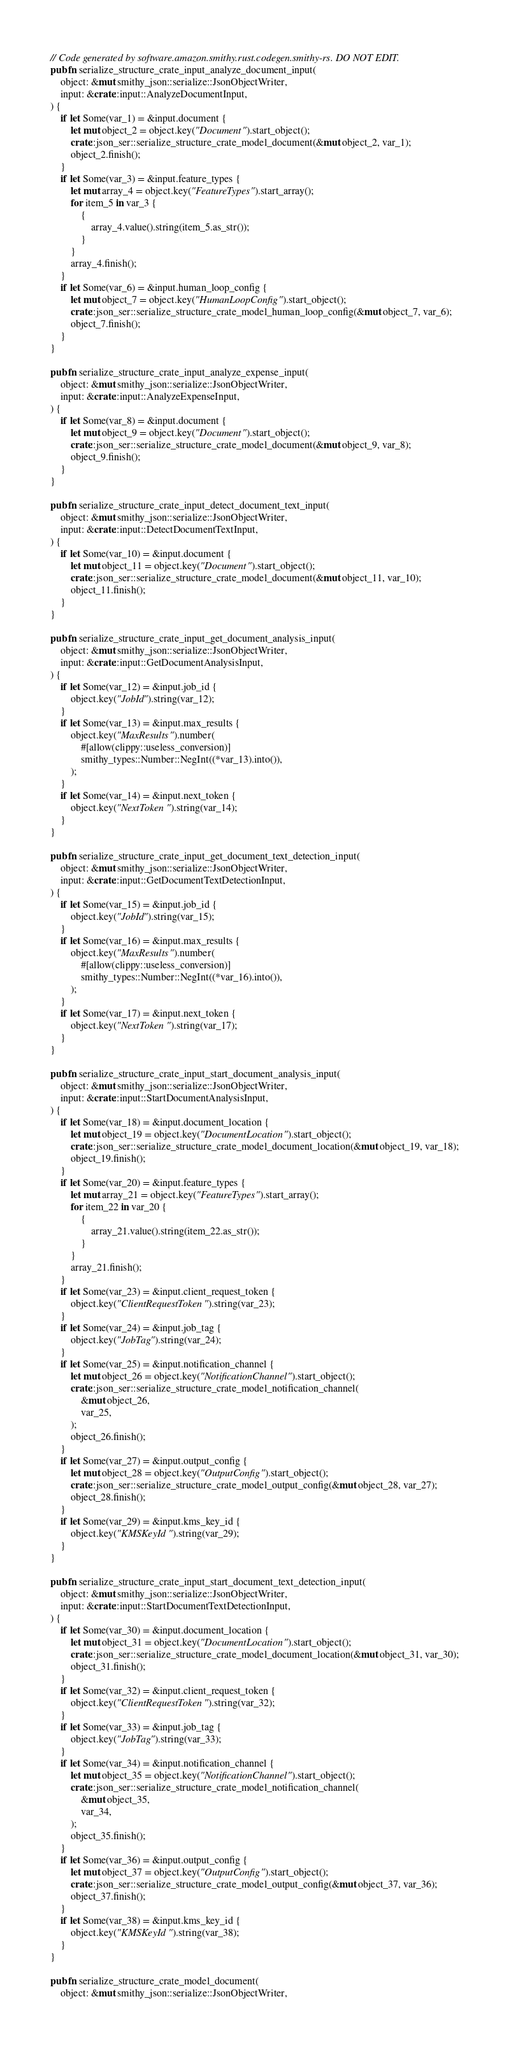Convert code to text. <code><loc_0><loc_0><loc_500><loc_500><_Rust_>// Code generated by software.amazon.smithy.rust.codegen.smithy-rs. DO NOT EDIT.
pub fn serialize_structure_crate_input_analyze_document_input(
    object: &mut smithy_json::serialize::JsonObjectWriter,
    input: &crate::input::AnalyzeDocumentInput,
) {
    if let Some(var_1) = &input.document {
        let mut object_2 = object.key("Document").start_object();
        crate::json_ser::serialize_structure_crate_model_document(&mut object_2, var_1);
        object_2.finish();
    }
    if let Some(var_3) = &input.feature_types {
        let mut array_4 = object.key("FeatureTypes").start_array();
        for item_5 in var_3 {
            {
                array_4.value().string(item_5.as_str());
            }
        }
        array_4.finish();
    }
    if let Some(var_6) = &input.human_loop_config {
        let mut object_7 = object.key("HumanLoopConfig").start_object();
        crate::json_ser::serialize_structure_crate_model_human_loop_config(&mut object_7, var_6);
        object_7.finish();
    }
}

pub fn serialize_structure_crate_input_analyze_expense_input(
    object: &mut smithy_json::serialize::JsonObjectWriter,
    input: &crate::input::AnalyzeExpenseInput,
) {
    if let Some(var_8) = &input.document {
        let mut object_9 = object.key("Document").start_object();
        crate::json_ser::serialize_structure_crate_model_document(&mut object_9, var_8);
        object_9.finish();
    }
}

pub fn serialize_structure_crate_input_detect_document_text_input(
    object: &mut smithy_json::serialize::JsonObjectWriter,
    input: &crate::input::DetectDocumentTextInput,
) {
    if let Some(var_10) = &input.document {
        let mut object_11 = object.key("Document").start_object();
        crate::json_ser::serialize_structure_crate_model_document(&mut object_11, var_10);
        object_11.finish();
    }
}

pub fn serialize_structure_crate_input_get_document_analysis_input(
    object: &mut smithy_json::serialize::JsonObjectWriter,
    input: &crate::input::GetDocumentAnalysisInput,
) {
    if let Some(var_12) = &input.job_id {
        object.key("JobId").string(var_12);
    }
    if let Some(var_13) = &input.max_results {
        object.key("MaxResults").number(
            #[allow(clippy::useless_conversion)]
            smithy_types::Number::NegInt((*var_13).into()),
        );
    }
    if let Some(var_14) = &input.next_token {
        object.key("NextToken").string(var_14);
    }
}

pub fn serialize_structure_crate_input_get_document_text_detection_input(
    object: &mut smithy_json::serialize::JsonObjectWriter,
    input: &crate::input::GetDocumentTextDetectionInput,
) {
    if let Some(var_15) = &input.job_id {
        object.key("JobId").string(var_15);
    }
    if let Some(var_16) = &input.max_results {
        object.key("MaxResults").number(
            #[allow(clippy::useless_conversion)]
            smithy_types::Number::NegInt((*var_16).into()),
        );
    }
    if let Some(var_17) = &input.next_token {
        object.key("NextToken").string(var_17);
    }
}

pub fn serialize_structure_crate_input_start_document_analysis_input(
    object: &mut smithy_json::serialize::JsonObjectWriter,
    input: &crate::input::StartDocumentAnalysisInput,
) {
    if let Some(var_18) = &input.document_location {
        let mut object_19 = object.key("DocumentLocation").start_object();
        crate::json_ser::serialize_structure_crate_model_document_location(&mut object_19, var_18);
        object_19.finish();
    }
    if let Some(var_20) = &input.feature_types {
        let mut array_21 = object.key("FeatureTypes").start_array();
        for item_22 in var_20 {
            {
                array_21.value().string(item_22.as_str());
            }
        }
        array_21.finish();
    }
    if let Some(var_23) = &input.client_request_token {
        object.key("ClientRequestToken").string(var_23);
    }
    if let Some(var_24) = &input.job_tag {
        object.key("JobTag").string(var_24);
    }
    if let Some(var_25) = &input.notification_channel {
        let mut object_26 = object.key("NotificationChannel").start_object();
        crate::json_ser::serialize_structure_crate_model_notification_channel(
            &mut object_26,
            var_25,
        );
        object_26.finish();
    }
    if let Some(var_27) = &input.output_config {
        let mut object_28 = object.key("OutputConfig").start_object();
        crate::json_ser::serialize_structure_crate_model_output_config(&mut object_28, var_27);
        object_28.finish();
    }
    if let Some(var_29) = &input.kms_key_id {
        object.key("KMSKeyId").string(var_29);
    }
}

pub fn serialize_structure_crate_input_start_document_text_detection_input(
    object: &mut smithy_json::serialize::JsonObjectWriter,
    input: &crate::input::StartDocumentTextDetectionInput,
) {
    if let Some(var_30) = &input.document_location {
        let mut object_31 = object.key("DocumentLocation").start_object();
        crate::json_ser::serialize_structure_crate_model_document_location(&mut object_31, var_30);
        object_31.finish();
    }
    if let Some(var_32) = &input.client_request_token {
        object.key("ClientRequestToken").string(var_32);
    }
    if let Some(var_33) = &input.job_tag {
        object.key("JobTag").string(var_33);
    }
    if let Some(var_34) = &input.notification_channel {
        let mut object_35 = object.key("NotificationChannel").start_object();
        crate::json_ser::serialize_structure_crate_model_notification_channel(
            &mut object_35,
            var_34,
        );
        object_35.finish();
    }
    if let Some(var_36) = &input.output_config {
        let mut object_37 = object.key("OutputConfig").start_object();
        crate::json_ser::serialize_structure_crate_model_output_config(&mut object_37, var_36);
        object_37.finish();
    }
    if let Some(var_38) = &input.kms_key_id {
        object.key("KMSKeyId").string(var_38);
    }
}

pub fn serialize_structure_crate_model_document(
    object: &mut smithy_json::serialize::JsonObjectWriter,</code> 